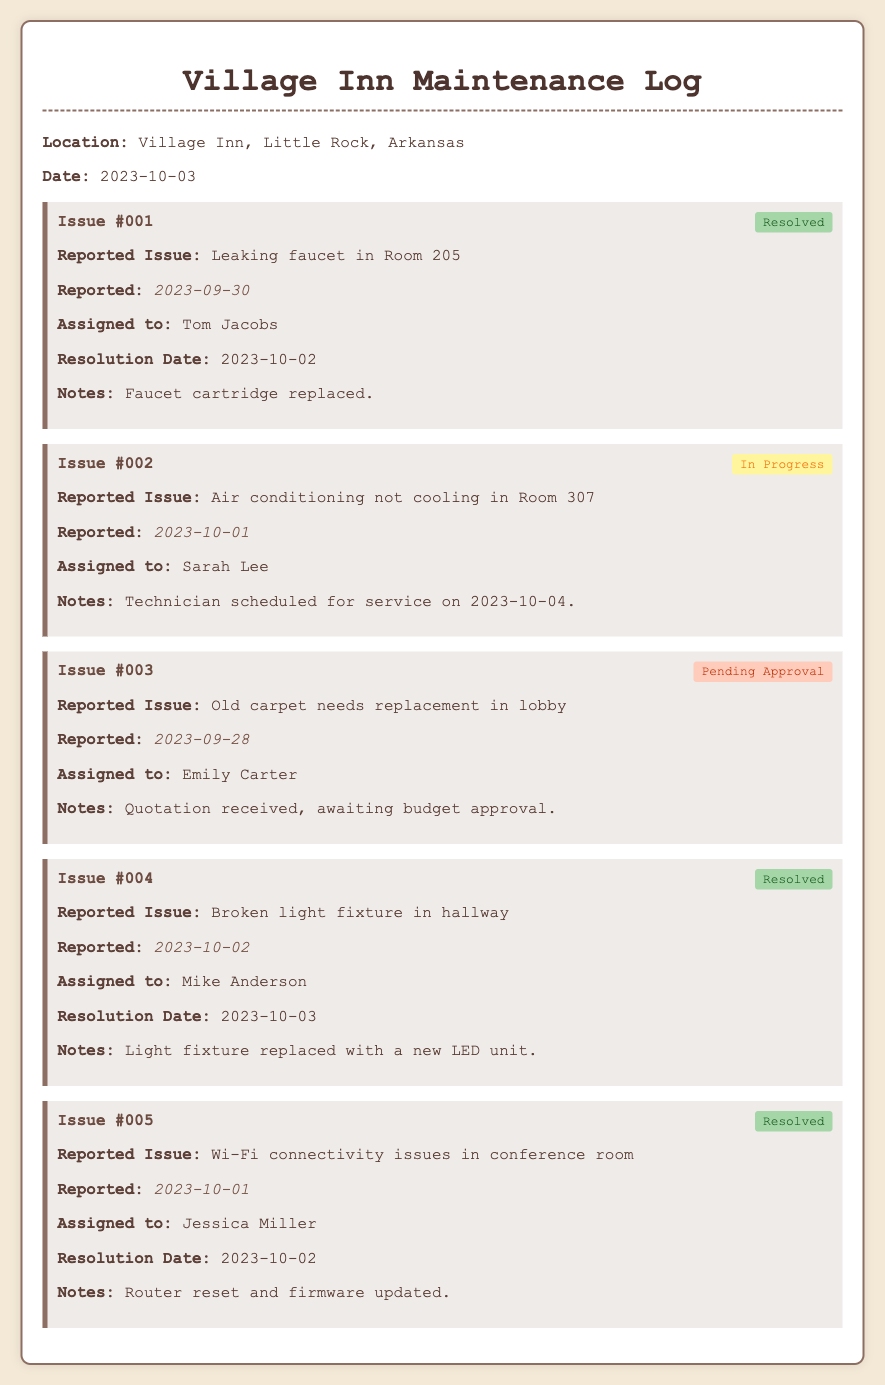What is the location of the maintenance log? The location is specified in the document.
Answer: Village Inn, Little Rock, Arkansas What is the date of the maintenance log? The date is provided at the beginning of the document.
Answer: 2023-10-03 Who reported the issue with the leaking faucet? The report details who was assigned to each issue, including the leaking faucet.
Answer: Tom Jacobs What is the status of the air conditioning issue in Room 307? The current status of the air conditioning issue is noted in the log entry.
Answer: In Progress When was the broken light fixture in the hallway resolved? The resolution date for the broken light fixture is mentioned in the log entry.
Answer: 2023-10-03 What was the resolution for the Wi-Fi connectivity issues? The notes section details the actions taken to resolve the connectivity issues.
Answer: Router reset and firmware updated Which issue is pending approval? The document states which issues are still awaiting action or approval.
Answer: Old carpet needs replacement in lobby How many issues have been resolved as of the log date? The document lists resolved issues, allowing for a count.
Answer: 3 Who is assigned to the carpet replacement issue? The assignment of issues includes the responsible person for each reported case.
Answer: Emily Carter 